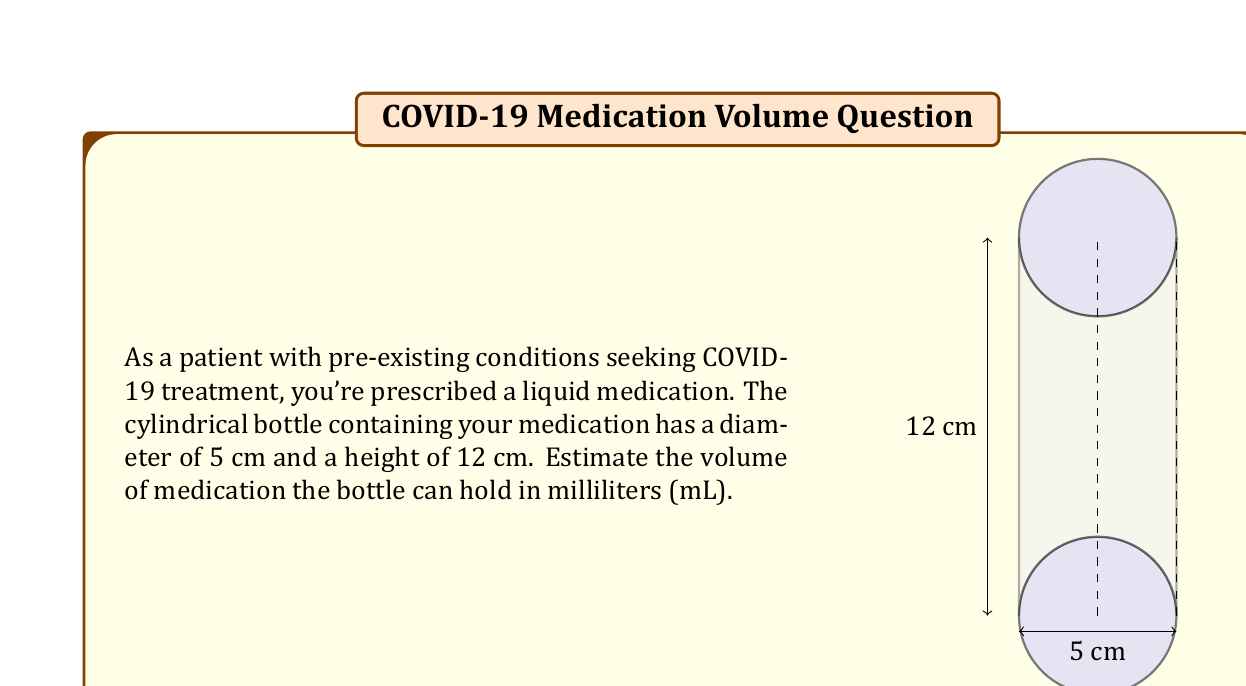Give your solution to this math problem. Let's approach this step-by-step:

1) The volume of a cylinder is given by the formula:
   $$V = \pi r^2 h$$
   where $r$ is the radius and $h$ is the height.

2) We're given the diameter (5 cm) and height (12 cm). First, let's calculate the radius:
   $$r = \frac{diameter}{2} = \frac{5}{2} = 2.5 \text{ cm}$$

3) Now we can plug our values into the formula:
   $$V = \pi (2.5 \text{ cm})^2 (12 \text{ cm})$$

4) Let's calculate:
   $$V = \pi (6.25 \text{ cm}^2) (12 \text{ cm})$$
   $$V = 75\pi \text{ cm}^3$$

5) We can use 3.14 as an approximation for $\pi$:
   $$V \approx 75 * 3.14 = 235.5 \text{ cm}^3$$

6) Since 1 cm³ = 1 mL, our answer is approximately 235.5 mL.

7) Rounding to a whole number for estimation:
   $$V \approx 236 \text{ mL}$$
Answer: 236 mL 